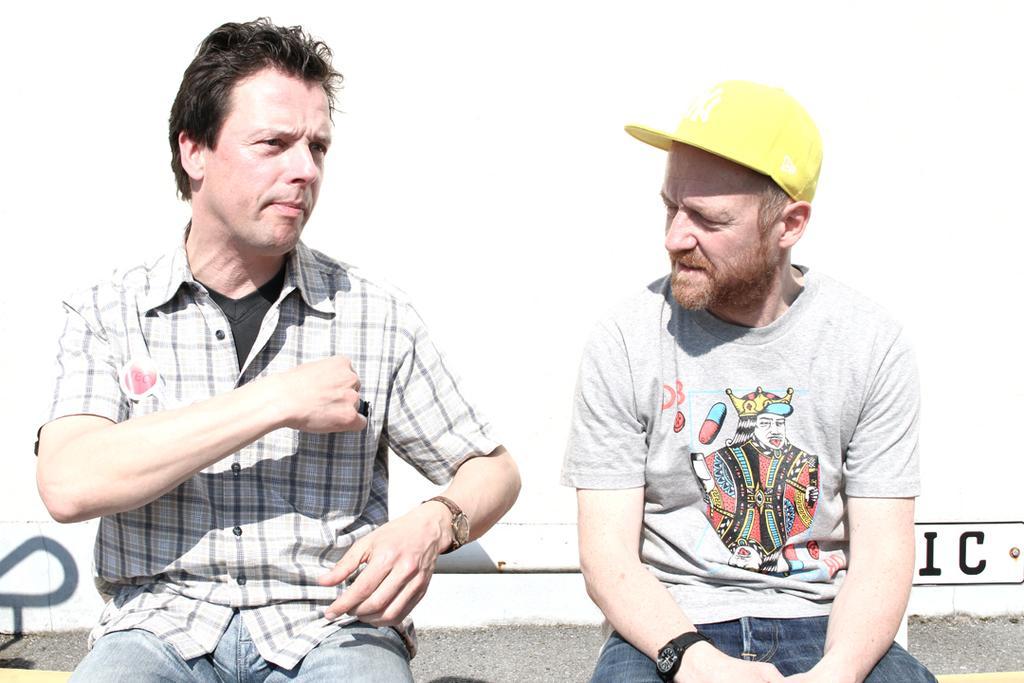In one or two sentences, can you explain what this image depicts? In this image I can see two persons sitting, the person at right is wearing white color shirt and the person at left is wearing white and gray color dress and I can see the white color background. 